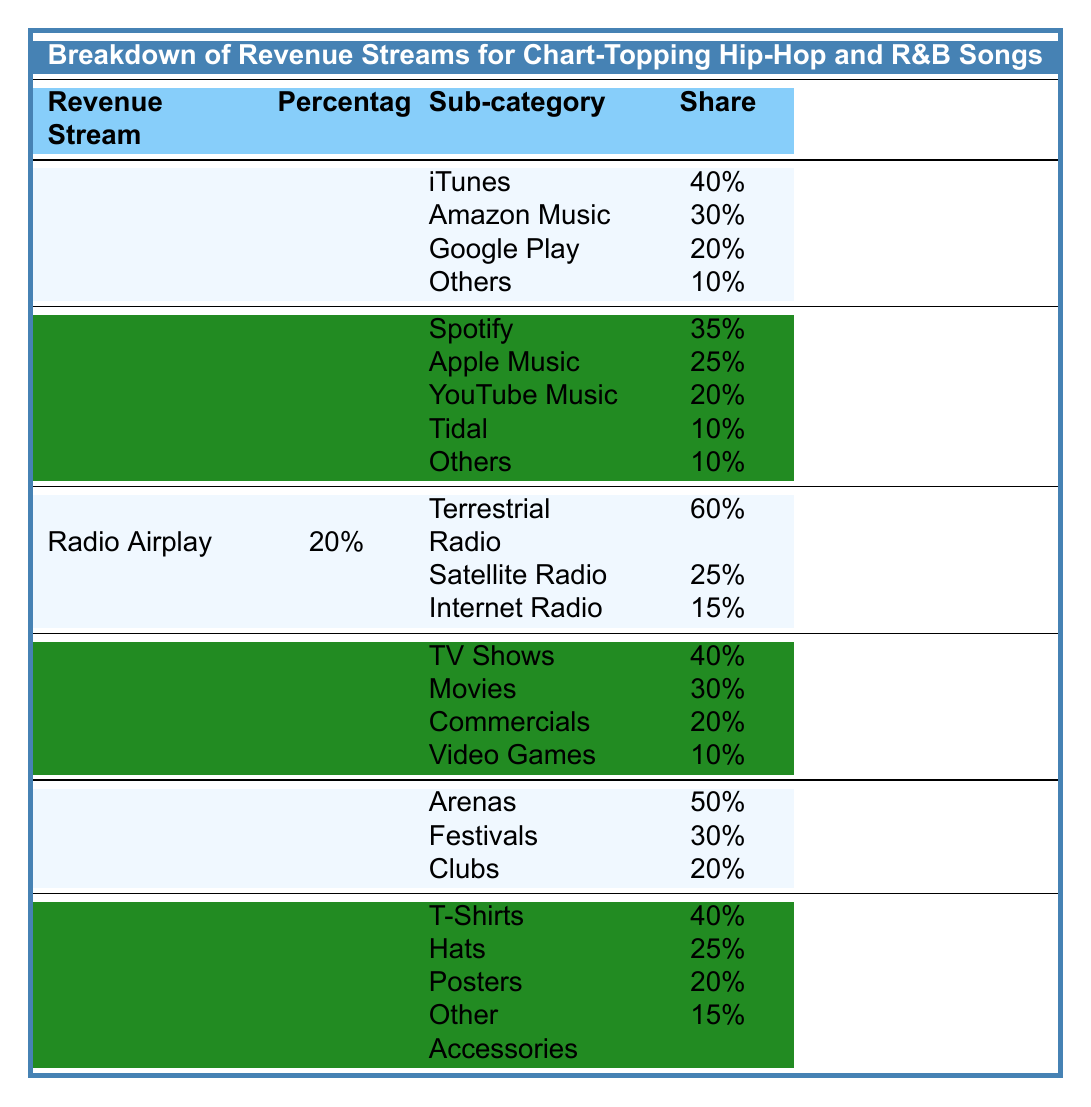What percentage of revenue comes from streaming? The table shows that streaming constitutes 45% of the revenue streams for chart-topping hip-hop and R&B songs.
Answer: 45% Which platform has the highest share in digital downloads? According to the table, iTunes has the highest share at 40% within the digital downloads category.
Answer: iTunes What is the total percentage share of 'Others' in streaming platforms? In the streaming category, 'Others' has a share of 10%, and since it's only one mention, that is the total percentage share for 'Others' in streaming.
Answer: 10% Is there a higher percentage of revenue from digital downloads or live performances? Digital downloads account for 15%, while live performances account for 8%. Since 15% is greater than 8%, digital downloads have a higher percentage.
Answer: Yes What is the combined share of Tidal and YouTube Music in streaming? To find the combined share, add Tidal's 10% and YouTube Music's 20%: 10% + 20% = 30%.
Answer: 30% Which revenue stream has the least percentage contribution? The table indicates that merchandise has the least contribution at 2%, making it the revenue stream with the least percentage.
Answer: Merchandise What types of radio airplay are included in the table? The table lists terrestrial radio, satellite radio, and internet radio as types of radio airplay with respective shares.
Answer: Terrestrial radio, Satellite radio, Internet radio Which category accounts for the largest share in sync licensing? In sync licensing, TV shows have the largest share at 40%, making it the category with the highest percentage in sync licensing.
Answer: TV Shows What percentage of overall revenue does radio airplay contribute? The table shows that radio airplay contributes 20% to the overall revenue streams.
Answer: 20% If we add the shares of T-Shirts and Hats in merchandise, what do we get? T-Shirts account for 40% and Hats for 25%. Adding them gives: 40% + 25% = 65%.
Answer: 65% 